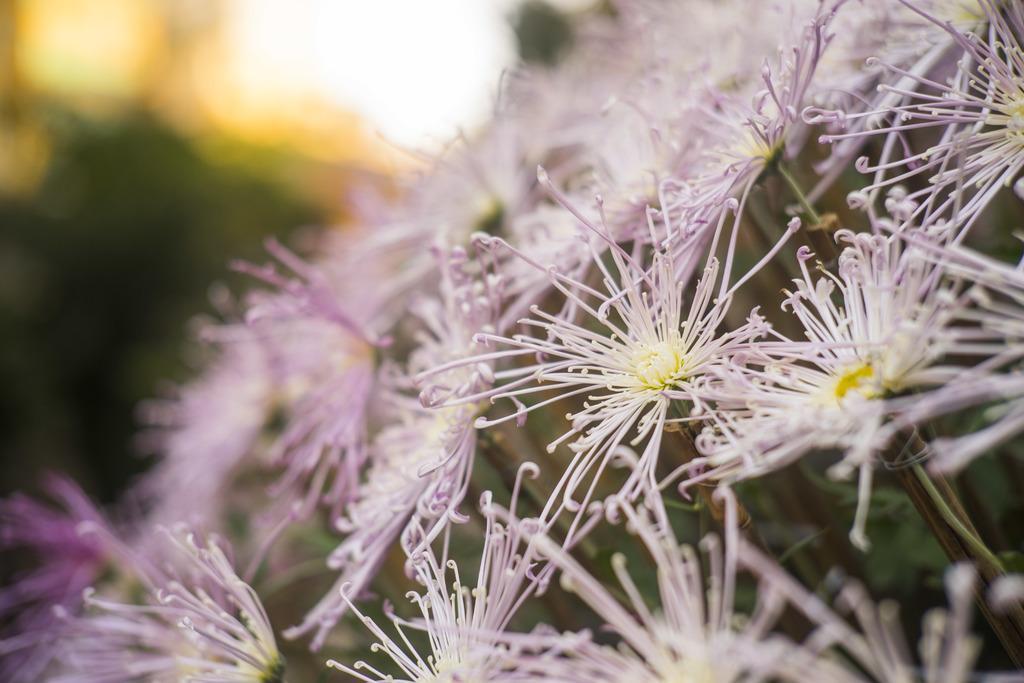In one or two sentences, can you explain what this image depicts? In this picture we can see a few flowers. Background is blurry. 